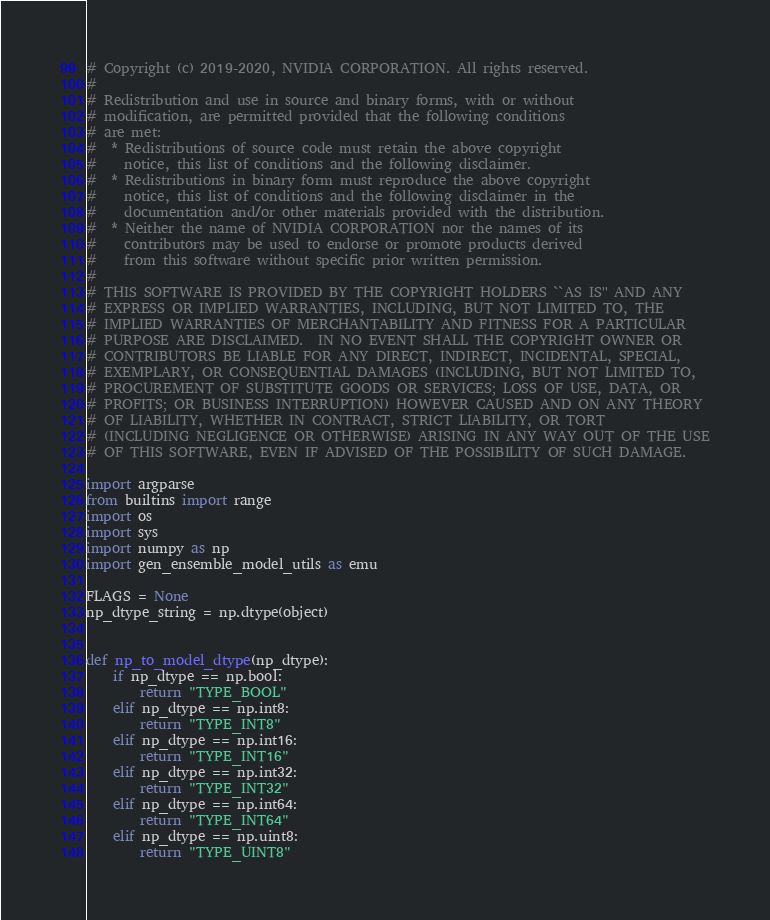Convert code to text. <code><loc_0><loc_0><loc_500><loc_500><_Python_># Copyright (c) 2019-2020, NVIDIA CORPORATION. All rights reserved.
#
# Redistribution and use in source and binary forms, with or without
# modification, are permitted provided that the following conditions
# are met:
#  * Redistributions of source code must retain the above copyright
#    notice, this list of conditions and the following disclaimer.
#  * Redistributions in binary form must reproduce the above copyright
#    notice, this list of conditions and the following disclaimer in the
#    documentation and/or other materials provided with the distribution.
#  * Neither the name of NVIDIA CORPORATION nor the names of its
#    contributors may be used to endorse or promote products derived
#    from this software without specific prior written permission.
#
# THIS SOFTWARE IS PROVIDED BY THE COPYRIGHT HOLDERS ``AS IS'' AND ANY
# EXPRESS OR IMPLIED WARRANTIES, INCLUDING, BUT NOT LIMITED TO, THE
# IMPLIED WARRANTIES OF MERCHANTABILITY AND FITNESS FOR A PARTICULAR
# PURPOSE ARE DISCLAIMED.  IN NO EVENT SHALL THE COPYRIGHT OWNER OR
# CONTRIBUTORS BE LIABLE FOR ANY DIRECT, INDIRECT, INCIDENTAL, SPECIAL,
# EXEMPLARY, OR CONSEQUENTIAL DAMAGES (INCLUDING, BUT NOT LIMITED TO,
# PROCUREMENT OF SUBSTITUTE GOODS OR SERVICES; LOSS OF USE, DATA, OR
# PROFITS; OR BUSINESS INTERRUPTION) HOWEVER CAUSED AND ON ANY THEORY
# OF LIABILITY, WHETHER IN CONTRACT, STRICT LIABILITY, OR TORT
# (INCLUDING NEGLIGENCE OR OTHERWISE) ARISING IN ANY WAY OUT OF THE USE
# OF THIS SOFTWARE, EVEN IF ADVISED OF THE POSSIBILITY OF SUCH DAMAGE.

import argparse
from builtins import range
import os
import sys
import numpy as np
import gen_ensemble_model_utils as emu

FLAGS = None
np_dtype_string = np.dtype(object)


def np_to_model_dtype(np_dtype):
    if np_dtype == np.bool:
        return "TYPE_BOOL"
    elif np_dtype == np.int8:
        return "TYPE_INT8"
    elif np_dtype == np.int16:
        return "TYPE_INT16"
    elif np_dtype == np.int32:
        return "TYPE_INT32"
    elif np_dtype == np.int64:
        return "TYPE_INT64"
    elif np_dtype == np.uint8:
        return "TYPE_UINT8"</code> 